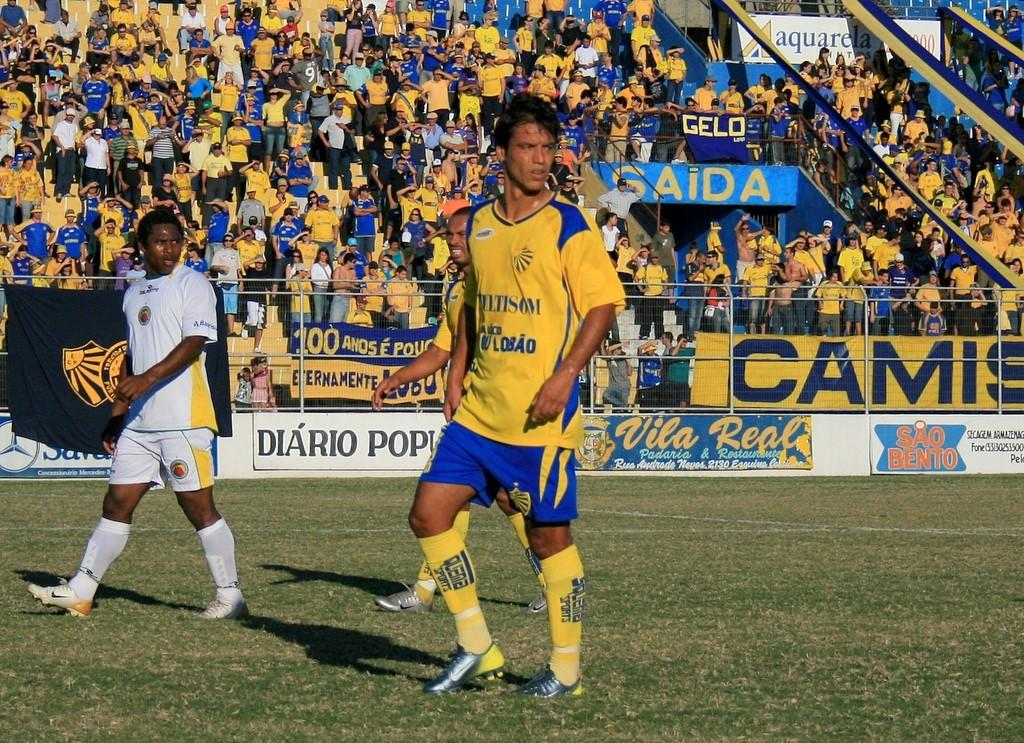<image>
Give a short and clear explanation of the subsequent image. Players on a field with an advert reading CAMIS in the background. 